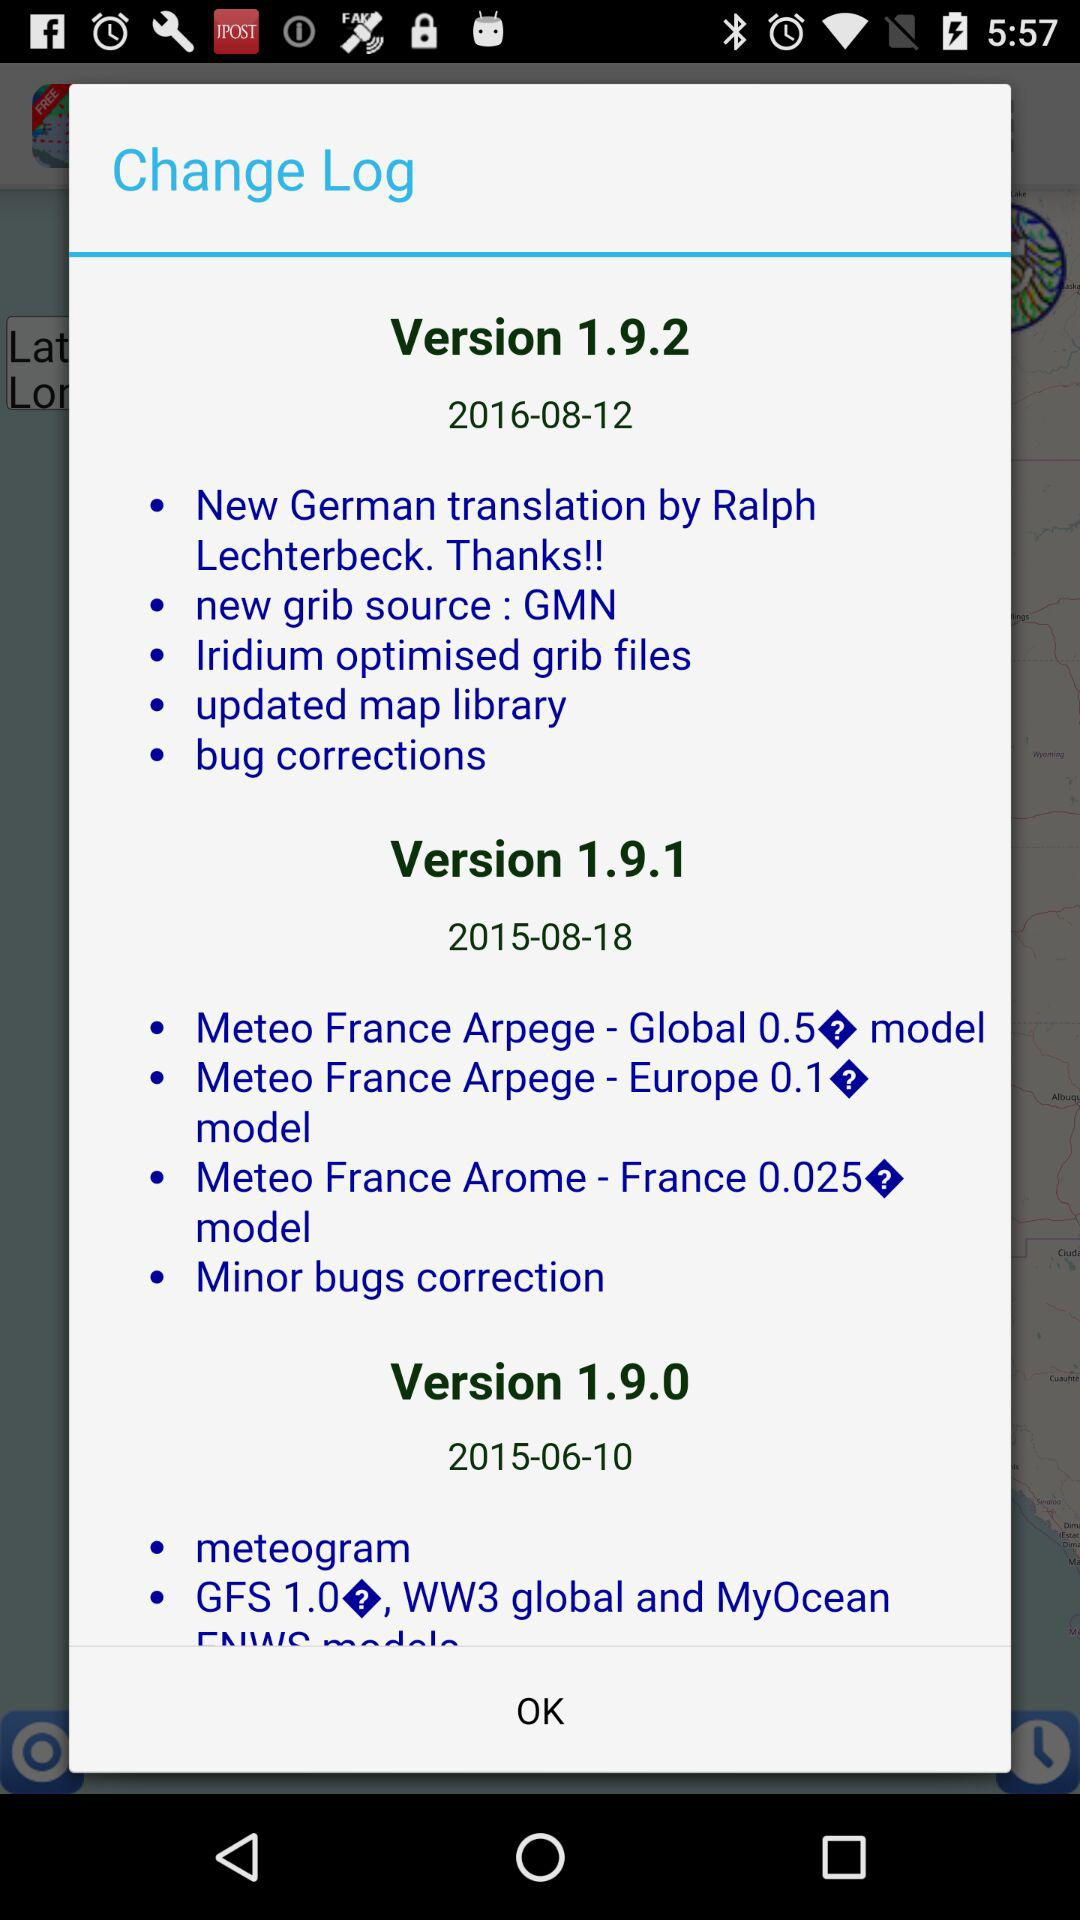What is the source of the new grib? The source of the new grib is GMN. 